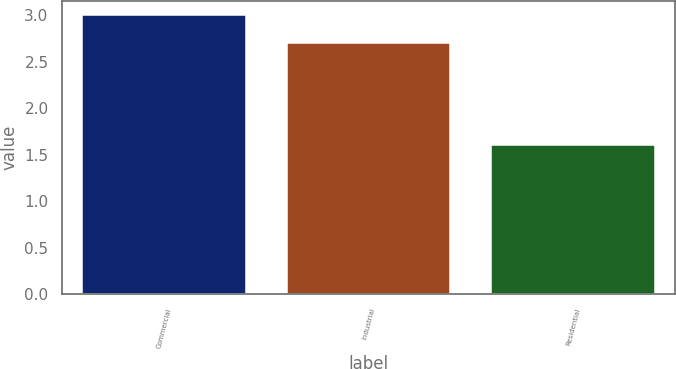<chart> <loc_0><loc_0><loc_500><loc_500><bar_chart><fcel>Commercial<fcel>Industrial<fcel>Residential<nl><fcel>3<fcel>2.7<fcel>1.6<nl></chart> 